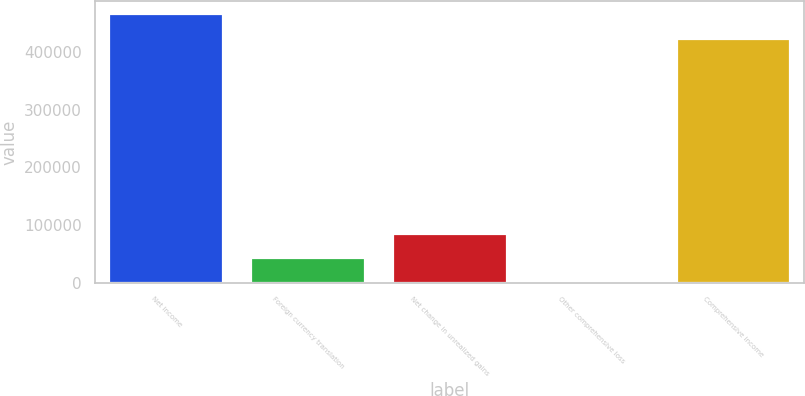Convert chart to OTSL. <chart><loc_0><loc_0><loc_500><loc_500><bar_chart><fcel>Net income<fcel>Foreign currency translation<fcel>Net change in unrealized gains<fcel>Other comprehensive loss<fcel>Comprehensive income<nl><fcel>465012<fcel>42736.8<fcel>85010.6<fcel>463<fcel>422738<nl></chart> 